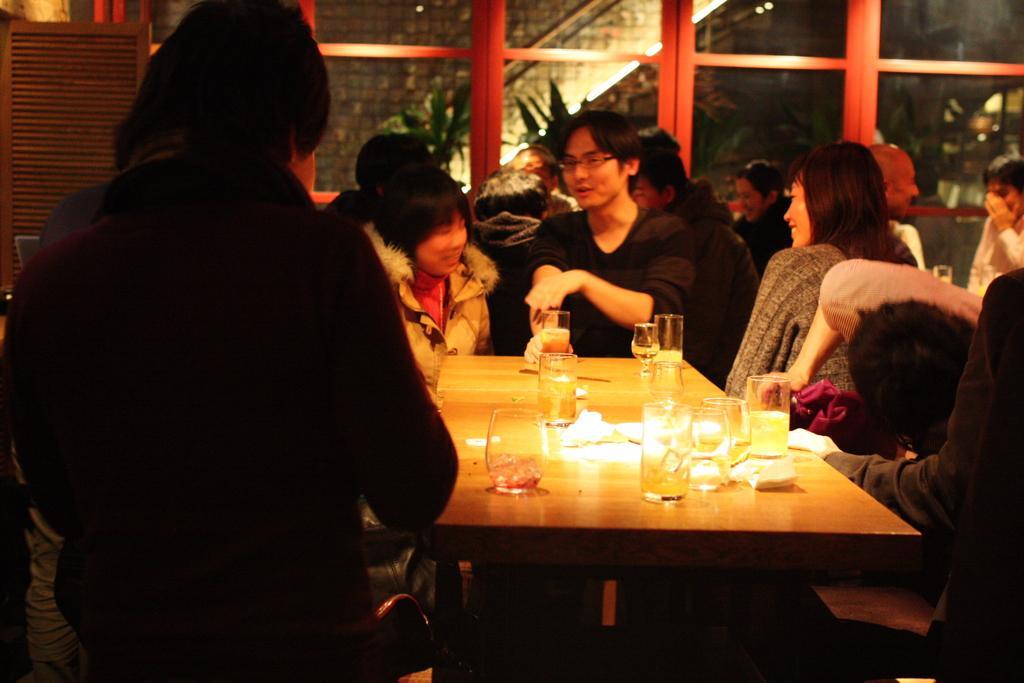Could you give a brief overview of what you see in this image? In this image there are group of people. On the table there are glass and a tissue. 